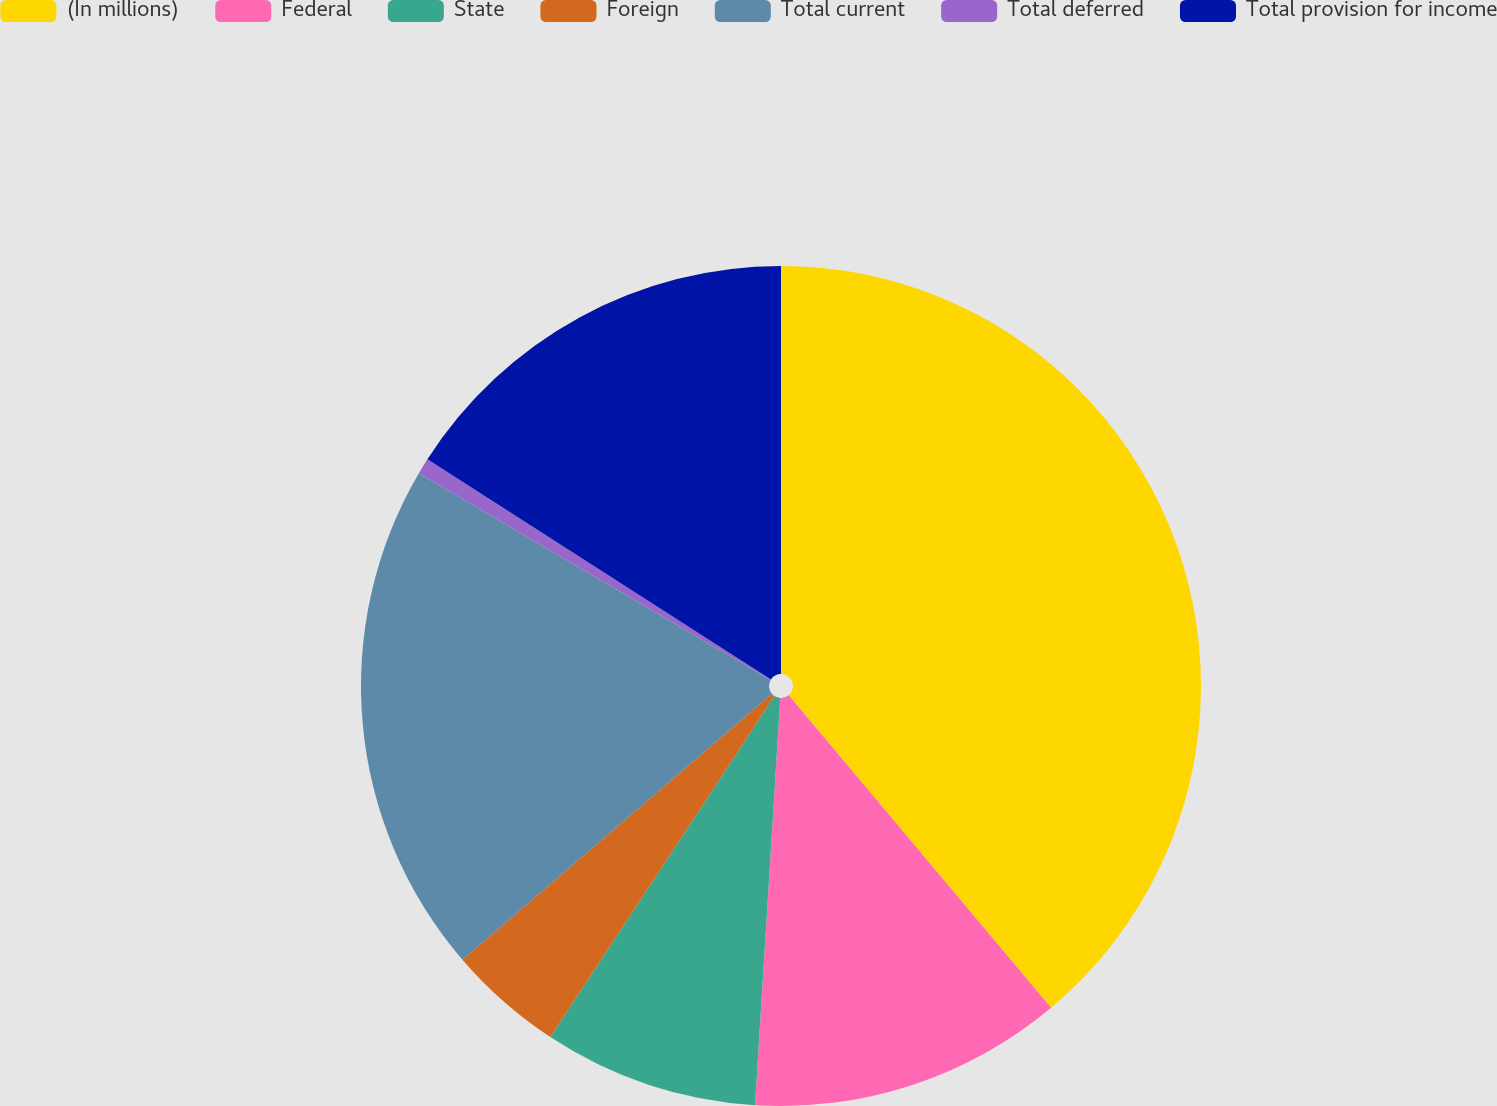<chart> <loc_0><loc_0><loc_500><loc_500><pie_chart><fcel>(In millions)<fcel>Federal<fcel>State<fcel>Foreign<fcel>Total current<fcel>Total deferred<fcel>Total provision for income<nl><fcel>38.89%<fcel>12.1%<fcel>8.27%<fcel>4.45%<fcel>19.75%<fcel>0.62%<fcel>15.93%<nl></chart> 